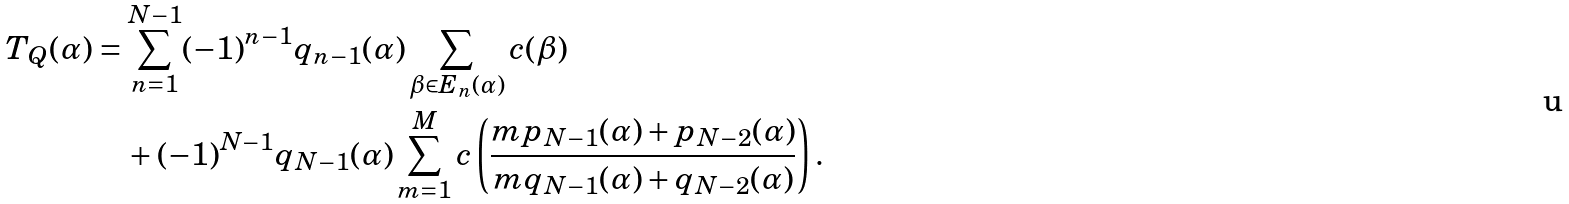<formula> <loc_0><loc_0><loc_500><loc_500>T _ { Q } ( \alpha ) & = \sum _ { n = 1 } ^ { N - 1 } ( - 1 ) ^ { n - 1 } q _ { n - 1 } ( \alpha ) \sum _ { \beta \in E _ { n } ( \alpha ) } c ( \beta ) \\ & \quad + ( - 1 ) ^ { N - 1 } q _ { N - 1 } ( \alpha ) \sum _ { m = 1 } ^ { M } c \left ( \frac { m p _ { N - 1 } ( \alpha ) + p _ { N - 2 } ( \alpha ) } { m q _ { N - 1 } ( \alpha ) + q _ { N - 2 } ( \alpha ) } \right ) .</formula> 